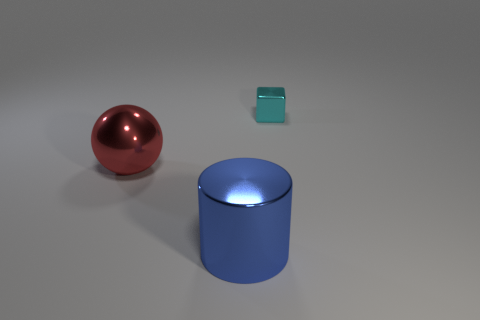Add 3 small brown rubber spheres. How many objects exist? 6 Subtract 1 balls. How many balls are left? 0 Add 2 big cubes. How many big cubes exist? 2 Subtract 0 brown cylinders. How many objects are left? 3 Subtract all brown balls. Subtract all purple blocks. How many balls are left? 1 Subtract all cyan blocks. How many purple cylinders are left? 0 Subtract all large cylinders. Subtract all large blue metallic objects. How many objects are left? 1 Add 2 small cyan cubes. How many small cyan cubes are left? 3 